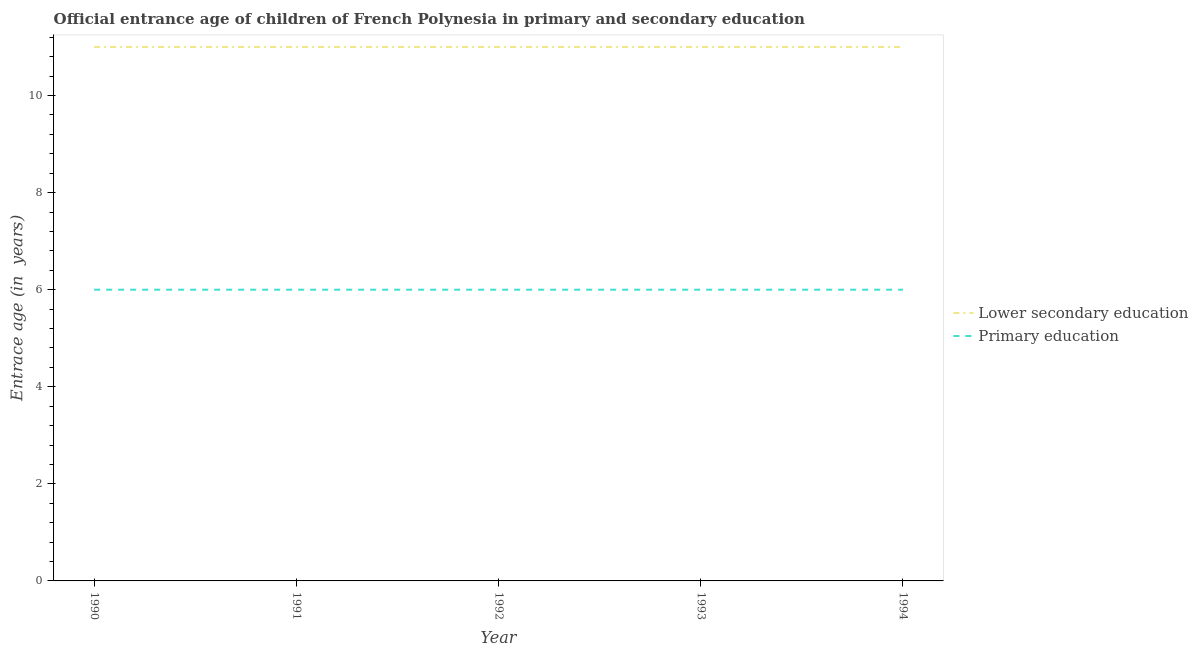How many different coloured lines are there?
Your answer should be compact. 2. What is the entrance age of children in lower secondary education in 1993?
Provide a short and direct response. 11. Across all years, what is the maximum entrance age of children in lower secondary education?
Your answer should be very brief. 11. Across all years, what is the minimum entrance age of chiildren in primary education?
Your response must be concise. 6. In which year was the entrance age of children in lower secondary education minimum?
Provide a succinct answer. 1990. What is the total entrance age of children in lower secondary education in the graph?
Provide a short and direct response. 55. What is the difference between the entrance age of chiildren in primary education in 1993 and that in 1994?
Provide a succinct answer. 0. What is the difference between the entrance age of children in lower secondary education in 1991 and the entrance age of chiildren in primary education in 1990?
Make the answer very short. 5. In the year 1993, what is the difference between the entrance age of chiildren in primary education and entrance age of children in lower secondary education?
Offer a terse response. -5. In how many years, is the entrance age of children in lower secondary education greater than 10.4 years?
Your answer should be very brief. 5. What is the difference between the highest and the second highest entrance age of children in lower secondary education?
Offer a very short reply. 0. How many years are there in the graph?
Make the answer very short. 5. Are the values on the major ticks of Y-axis written in scientific E-notation?
Provide a succinct answer. No. Does the graph contain grids?
Provide a short and direct response. No. How many legend labels are there?
Your response must be concise. 2. What is the title of the graph?
Your answer should be very brief. Official entrance age of children of French Polynesia in primary and secondary education. Does "Canada" appear as one of the legend labels in the graph?
Your answer should be very brief. No. What is the label or title of the Y-axis?
Your answer should be compact. Entrace age (in  years). What is the Entrace age (in  years) of Lower secondary education in 1990?
Provide a short and direct response. 11. What is the Entrace age (in  years) in Lower secondary education in 1992?
Offer a very short reply. 11. Across all years, what is the maximum Entrace age (in  years) in Lower secondary education?
Provide a succinct answer. 11. Across all years, what is the minimum Entrace age (in  years) of Lower secondary education?
Your response must be concise. 11. What is the total Entrace age (in  years) in Lower secondary education in the graph?
Provide a succinct answer. 55. What is the total Entrace age (in  years) of Primary education in the graph?
Provide a succinct answer. 30. What is the difference between the Entrace age (in  years) of Primary education in 1990 and that in 1991?
Your answer should be compact. 0. What is the difference between the Entrace age (in  years) of Lower secondary education in 1990 and that in 1992?
Give a very brief answer. 0. What is the difference between the Entrace age (in  years) of Lower secondary education in 1990 and that in 1993?
Offer a terse response. 0. What is the difference between the Entrace age (in  years) of Primary education in 1990 and that in 1993?
Your response must be concise. 0. What is the difference between the Entrace age (in  years) of Lower secondary education in 1990 and that in 1994?
Offer a very short reply. 0. What is the difference between the Entrace age (in  years) in Primary education in 1991 and that in 1992?
Keep it short and to the point. 0. What is the difference between the Entrace age (in  years) in Lower secondary education in 1991 and that in 1993?
Offer a terse response. 0. What is the difference between the Entrace age (in  years) in Primary education in 1991 and that in 1993?
Provide a succinct answer. 0. What is the difference between the Entrace age (in  years) of Primary education in 1992 and that in 1994?
Your answer should be compact. 0. What is the difference between the Entrace age (in  years) of Primary education in 1993 and that in 1994?
Your response must be concise. 0. What is the difference between the Entrace age (in  years) in Lower secondary education in 1990 and the Entrace age (in  years) in Primary education in 1992?
Keep it short and to the point. 5. What is the difference between the Entrace age (in  years) in Lower secondary education in 1990 and the Entrace age (in  years) in Primary education in 1993?
Provide a short and direct response. 5. What is the difference between the Entrace age (in  years) in Lower secondary education in 1991 and the Entrace age (in  years) in Primary education in 1992?
Your answer should be compact. 5. What is the difference between the Entrace age (in  years) of Lower secondary education in 1991 and the Entrace age (in  years) of Primary education in 1993?
Give a very brief answer. 5. What is the difference between the Entrace age (in  years) in Lower secondary education in 1992 and the Entrace age (in  years) in Primary education in 1993?
Give a very brief answer. 5. What is the average Entrace age (in  years) in Lower secondary education per year?
Keep it short and to the point. 11. In the year 1992, what is the difference between the Entrace age (in  years) in Lower secondary education and Entrace age (in  years) in Primary education?
Offer a terse response. 5. In the year 1993, what is the difference between the Entrace age (in  years) of Lower secondary education and Entrace age (in  years) of Primary education?
Give a very brief answer. 5. In the year 1994, what is the difference between the Entrace age (in  years) of Lower secondary education and Entrace age (in  years) of Primary education?
Provide a succinct answer. 5. What is the ratio of the Entrace age (in  years) in Lower secondary education in 1990 to that in 1991?
Your answer should be very brief. 1. What is the ratio of the Entrace age (in  years) in Primary education in 1990 to that in 1991?
Ensure brevity in your answer.  1. What is the ratio of the Entrace age (in  years) in Lower secondary education in 1990 to that in 1993?
Make the answer very short. 1. What is the ratio of the Entrace age (in  years) of Primary education in 1990 to that in 1993?
Give a very brief answer. 1. What is the ratio of the Entrace age (in  years) of Lower secondary education in 1991 to that in 1992?
Give a very brief answer. 1. What is the ratio of the Entrace age (in  years) of Lower secondary education in 1991 to that in 1993?
Provide a short and direct response. 1. What is the ratio of the Entrace age (in  years) of Primary education in 1991 to that in 1993?
Give a very brief answer. 1. What is the ratio of the Entrace age (in  years) of Primary education in 1992 to that in 1994?
Keep it short and to the point. 1. What is the difference between the highest and the second highest Entrace age (in  years) of Lower secondary education?
Ensure brevity in your answer.  0. What is the difference between the highest and the lowest Entrace age (in  years) of Lower secondary education?
Provide a succinct answer. 0. 